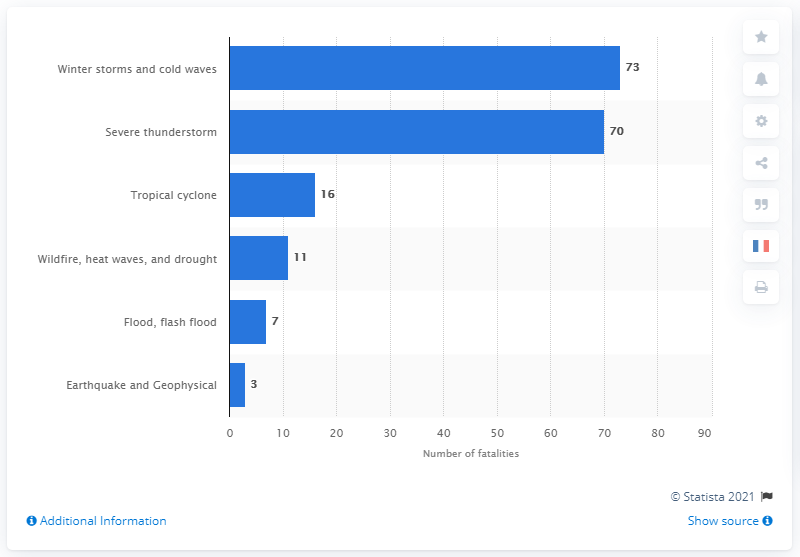Outline some significant characteristics in this image. In 2019, a total of 73 deaths were attributed to winter storms and cold weather in the United States. 